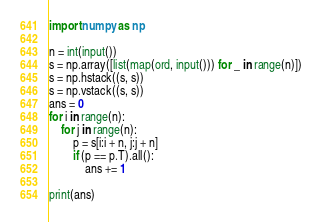<code> <loc_0><loc_0><loc_500><loc_500><_Python_>import numpy as np

n = int(input())
s = np.array([list(map(ord, input())) for _ in range(n)])
s = np.hstack((s, s))
s = np.vstack((s, s))
ans = 0
for i in range(n):
    for j in range(n):
        p = s[i:i + n, j:j + n]
        if (p == p.T).all():
            ans += 1

print(ans)
</code> 